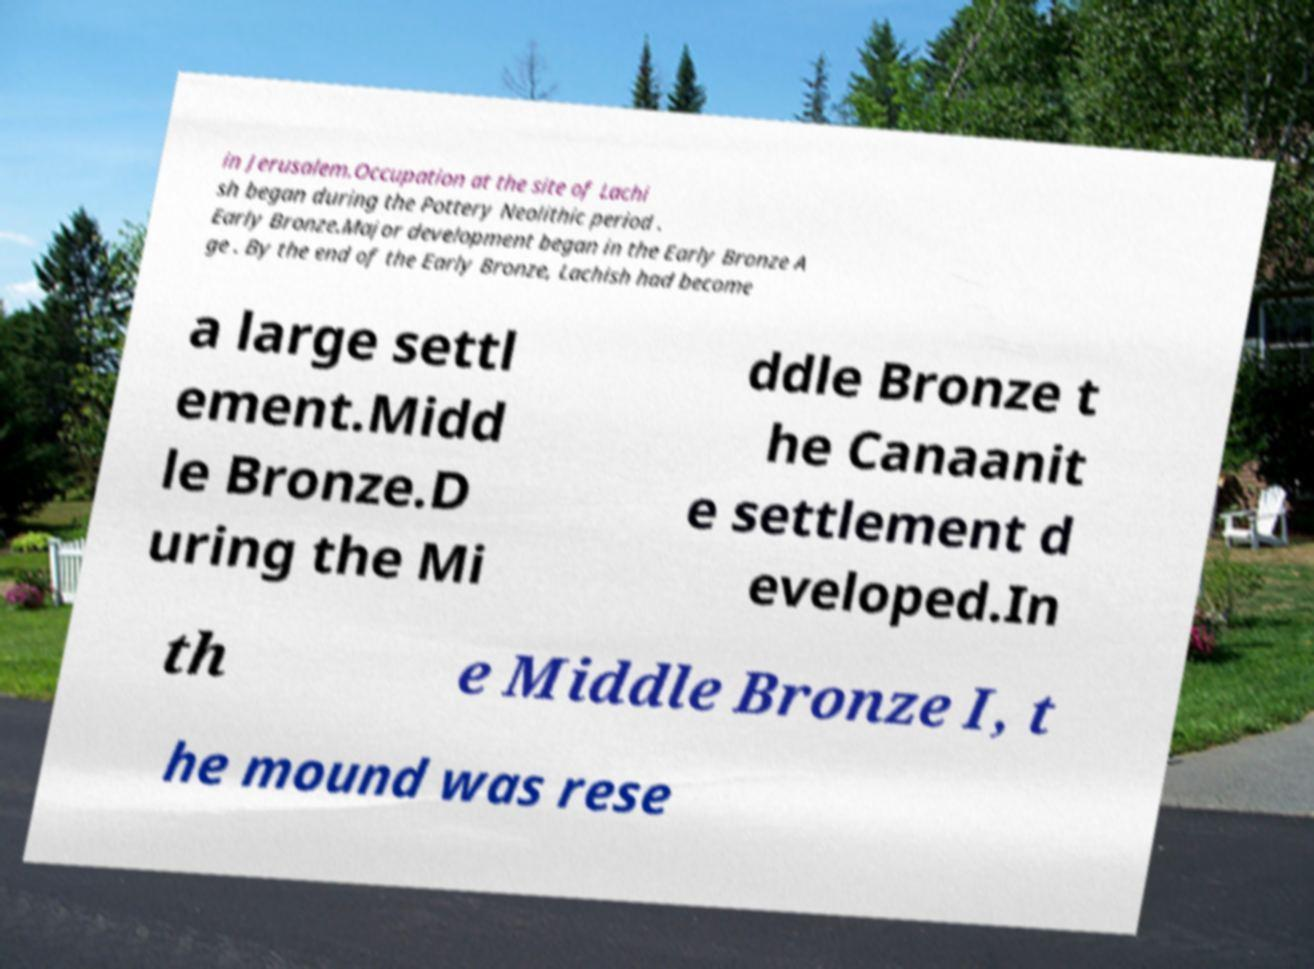What messages or text are displayed in this image? I need them in a readable, typed format. in Jerusalem.Occupation at the site of Lachi sh began during the Pottery Neolithic period . Early Bronze.Major development began in the Early Bronze A ge . By the end of the Early Bronze, Lachish had become a large settl ement.Midd le Bronze.D uring the Mi ddle Bronze t he Canaanit e settlement d eveloped.In th e Middle Bronze I, t he mound was rese 